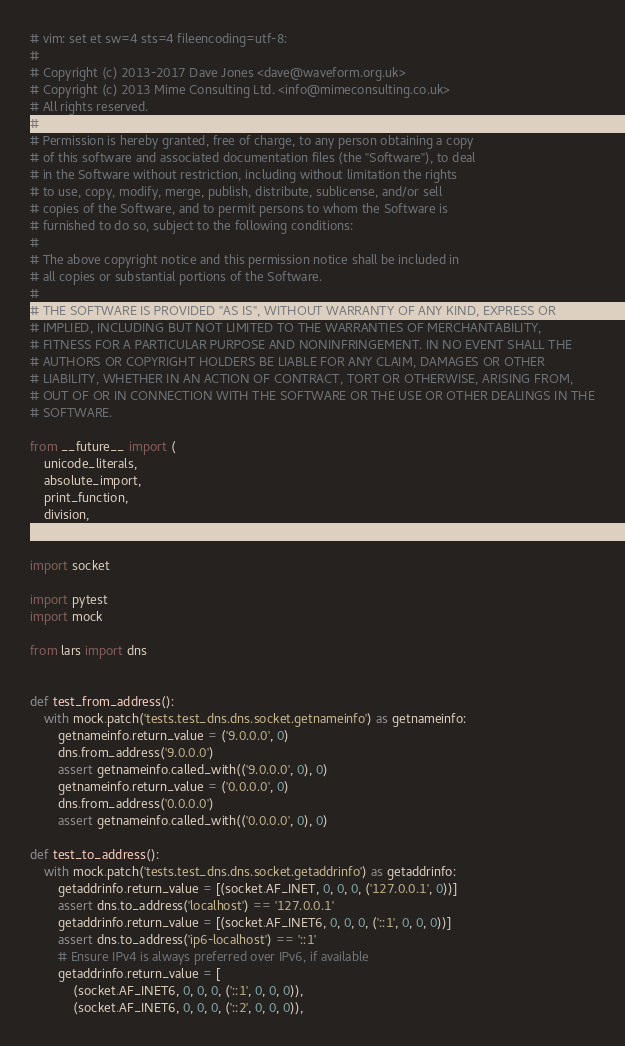Convert code to text. <code><loc_0><loc_0><loc_500><loc_500><_Python_># vim: set et sw=4 sts=4 fileencoding=utf-8:
#
# Copyright (c) 2013-2017 Dave Jones <dave@waveform.org.uk>
# Copyright (c) 2013 Mime Consulting Ltd. <info@mimeconsulting.co.uk>
# All rights reserved.
#
# Permission is hereby granted, free of charge, to any person obtaining a copy
# of this software and associated documentation files (the "Software"), to deal
# in the Software without restriction, including without limitation the rights
# to use, copy, modify, merge, publish, distribute, sublicense, and/or sell
# copies of the Software, and to permit persons to whom the Software is
# furnished to do so, subject to the following conditions:
#
# The above copyright notice and this permission notice shall be included in
# all copies or substantial portions of the Software.
#
# THE SOFTWARE IS PROVIDED "AS IS", WITHOUT WARRANTY OF ANY KIND, EXPRESS OR
# IMPLIED, INCLUDING BUT NOT LIMITED TO THE WARRANTIES OF MERCHANTABILITY,
# FITNESS FOR A PARTICULAR PURPOSE AND NONINFRINGEMENT. IN NO EVENT SHALL THE
# AUTHORS OR COPYRIGHT HOLDERS BE LIABLE FOR ANY CLAIM, DAMAGES OR OTHER
# LIABILITY, WHETHER IN AN ACTION OF CONTRACT, TORT OR OTHERWISE, ARISING FROM,
# OUT OF OR IN CONNECTION WITH THE SOFTWARE OR THE USE OR OTHER DEALINGS IN THE
# SOFTWARE.

from __future__ import (
    unicode_literals,
    absolute_import,
    print_function,
    division,
    )

import socket

import pytest
import mock

from lars import dns


def test_from_address():
    with mock.patch('tests.test_dns.dns.socket.getnameinfo') as getnameinfo:
        getnameinfo.return_value = ('9.0.0.0', 0)
        dns.from_address('9.0.0.0')
        assert getnameinfo.called_with(('9.0.0.0', 0), 0)
        getnameinfo.return_value = ('0.0.0.0', 0)
        dns.from_address('0.0.0.0')
        assert getnameinfo.called_with(('0.0.0.0', 0), 0)

def test_to_address():
    with mock.patch('tests.test_dns.dns.socket.getaddrinfo') as getaddrinfo:
        getaddrinfo.return_value = [(socket.AF_INET, 0, 0, 0, ('127.0.0.1', 0))]
        assert dns.to_address('localhost') == '127.0.0.1'
        getaddrinfo.return_value = [(socket.AF_INET6, 0, 0, 0, ('::1', 0, 0, 0))]
        assert dns.to_address('ip6-localhost') == '::1'
        # Ensure IPv4 is always preferred over IPv6, if available
        getaddrinfo.return_value = [
            (socket.AF_INET6, 0, 0, 0, ('::1', 0, 0, 0)),
            (socket.AF_INET6, 0, 0, 0, ('::2', 0, 0, 0)),</code> 